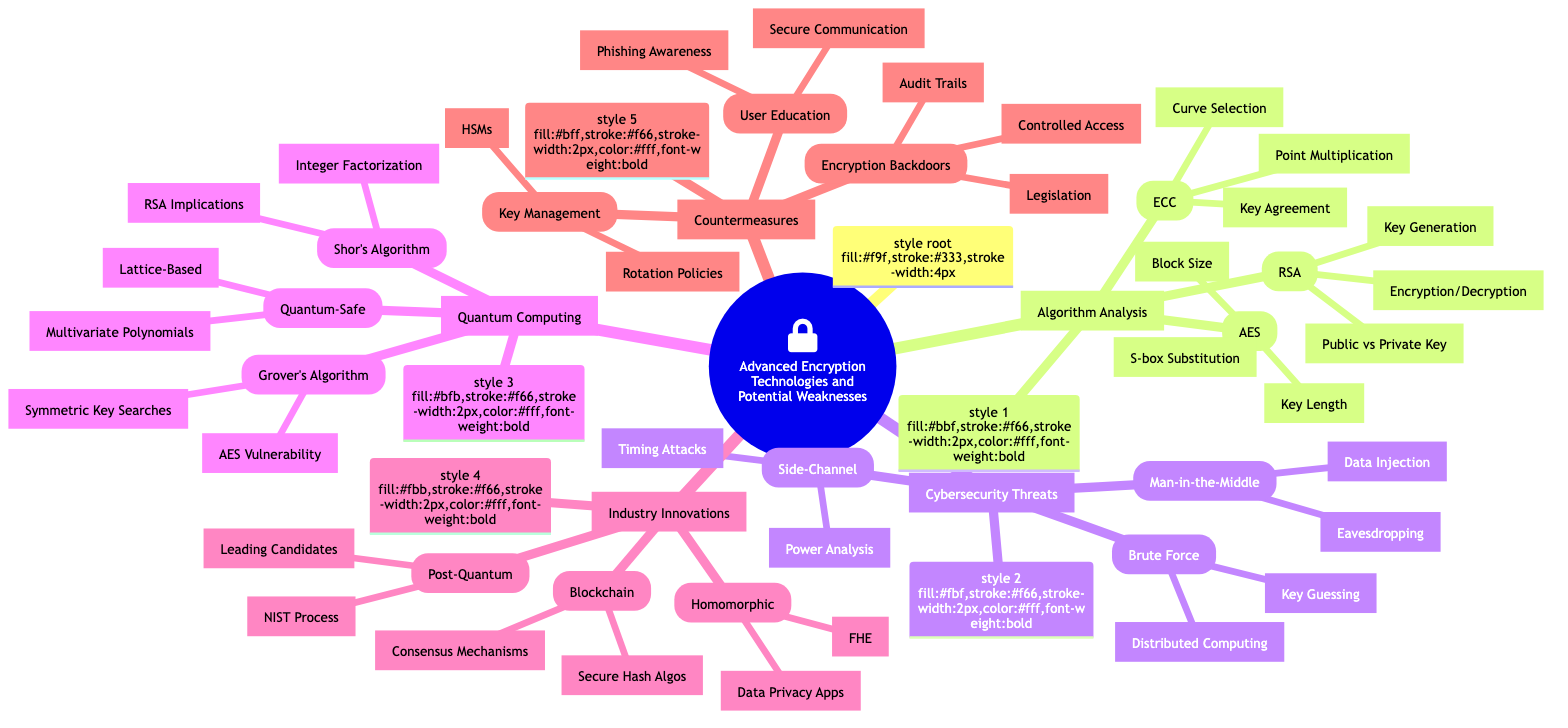What are the three main categories in the mind map? The main categories are Algorithm Analysis, Cybersecurity Threats, Quantum Computing, Industry Innovations, and Countermeasures.
Answer: Algorithm Analysis, Cybersecurity Threats, Quantum Computing, Industry Innovations, Countermeasures How many nodes are in the "Cybersecurity Threats" category? In the "Cybersecurity Threats" category, there are three main nodes: Brute Force Attacks, Side-Channel Attacks, and Man-in-the-Middle Attacks.
Answer: Three Which encryption method uses key length, block size, and S-box substitution? These characteristics pertain specifically to the AES (Advanced Encryption Standard) algorithm listed under "Algorithm Analysis."
Answer: AES What is the implication of Shor's Algorithm on RSA? Shor's Algorithm has implications for RSA due to its ability to efficiently factor large integers, compromising RSA's security.
Answer: RSA Implications Name one countermeasure related to encryption backdoors. One countermeasure mentioned is "Legislation and Regulation," indicating a structured approach to managing encryption backdoors.
Answer: Legislation Which cybersecurity threat involves eavesdropping and data injection? The threat that involves both eavesdropping and data injection is categorized under "Man-in-the-Middle Attacks."
Answer: Man-in-the-Middle Attacks How many leading candidates are involved in the Post-Quantum Cryptography section? The "Post-Quantum Cryptography" section mentions "Leading Candidates" as one of its aspects, indicating there are multiple candidates being evaluated.
Answer: Multiple What type of algorithms does homomorphic encryption encompass? Homomorphic encryption includes Fully Homomorphic Encryption (FHE), which allows computation on ciphertexts and has applications in data privacy.
Answer: Fully Homomorphic Encryption Which algorithm shows vulnerability with Grover's Algorithm? Grover's Algorithm shows a vulnerability for the AES, as it provides a quadratic speedup in symmetric key searches.
Answer: AES Vulnerability 